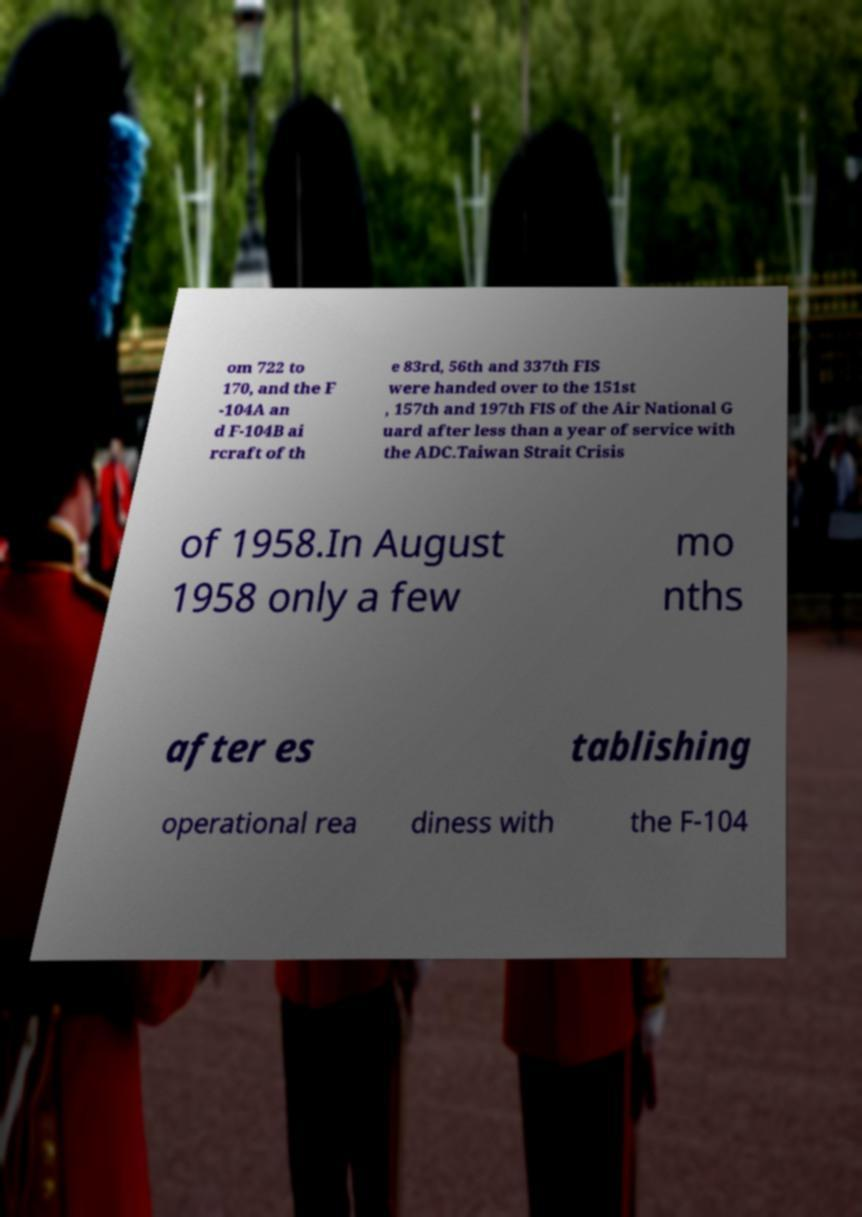Could you assist in decoding the text presented in this image and type it out clearly? om 722 to 170, and the F -104A an d F-104B ai rcraft of th e 83rd, 56th and 337th FIS were handed over to the 151st , 157th and 197th FIS of the Air National G uard after less than a year of service with the ADC.Taiwan Strait Crisis of 1958.In August 1958 only a few mo nths after es tablishing operational rea diness with the F-104 